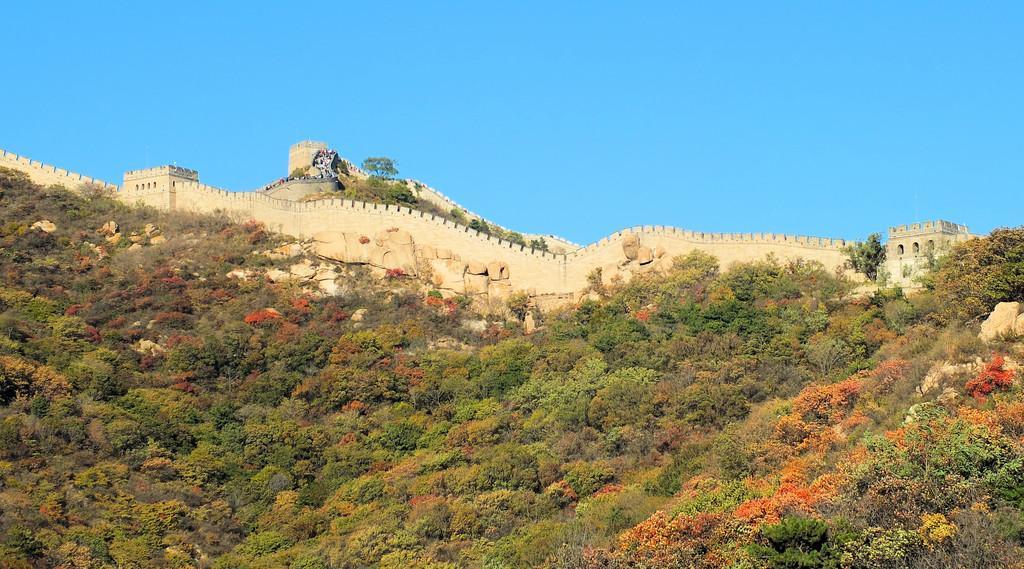How would you summarize this image in a sentence or two? In this image in the front there are trees and plants. In the background there is a fort and there are stones. 